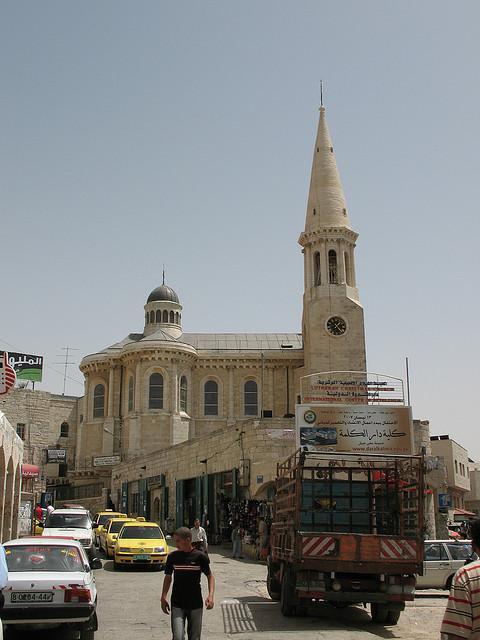What sound source can be found above the clock here?
Select the accurate answer and provide explanation: 'Answer: answer
Rationale: rationale.'
Options: Intercom, choir, boom box, bell. Answer: bell.
Rationale: There is a bell in the church's tower. 